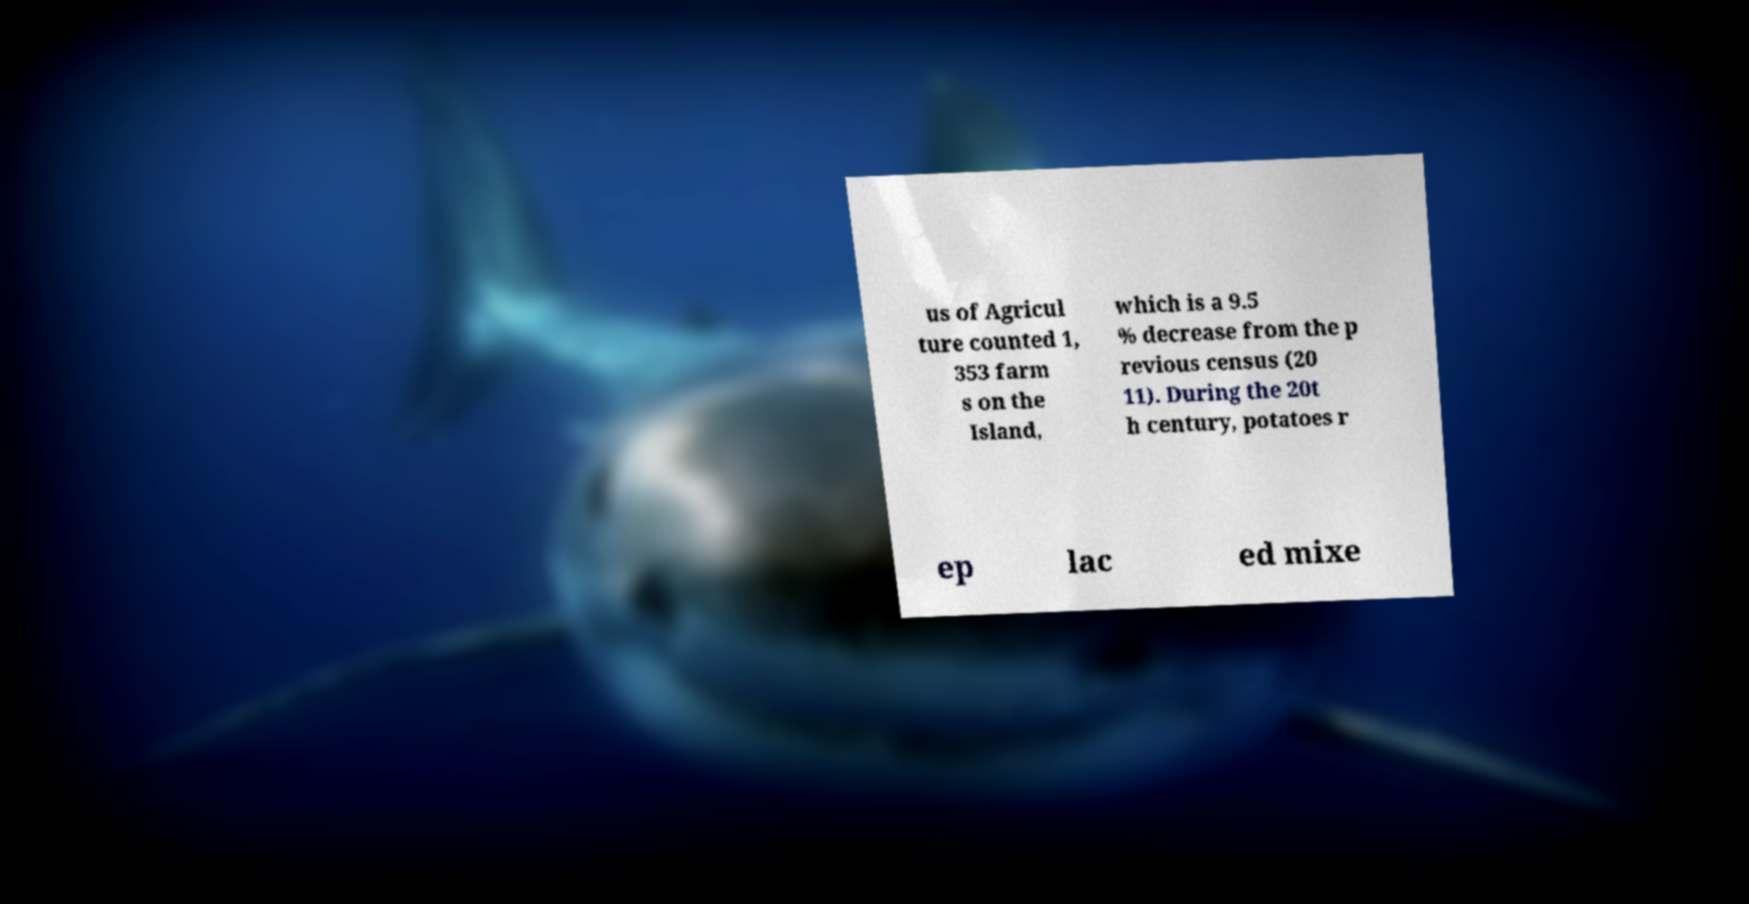Can you read and provide the text displayed in the image?This photo seems to have some interesting text. Can you extract and type it out for me? us of Agricul ture counted 1, 353 farm s on the Island, which is a 9.5 % decrease from the p revious census (20 11). During the 20t h century, potatoes r ep lac ed mixe 